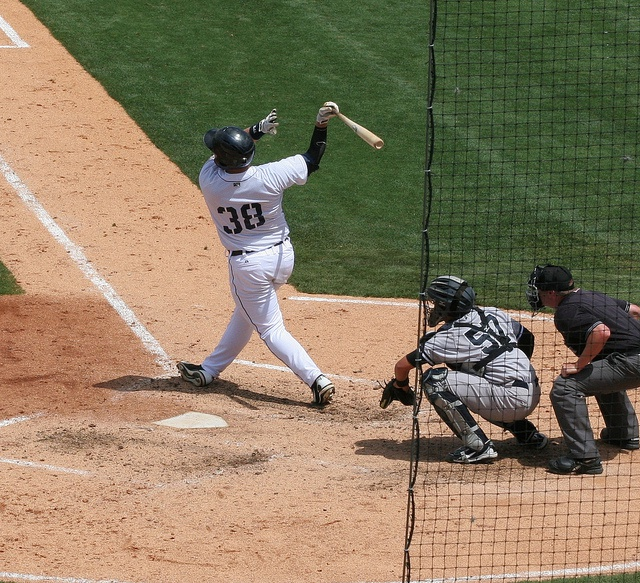Describe the objects in this image and their specific colors. I can see people in tan, gray, lavender, and black tones, people in tan, black, gray, darkgray, and lightgray tones, people in tan, black, gray, and maroon tones, baseball glove in tan, black, maroon, and gray tones, and baseball bat in tan, darkgreen, and gray tones in this image. 